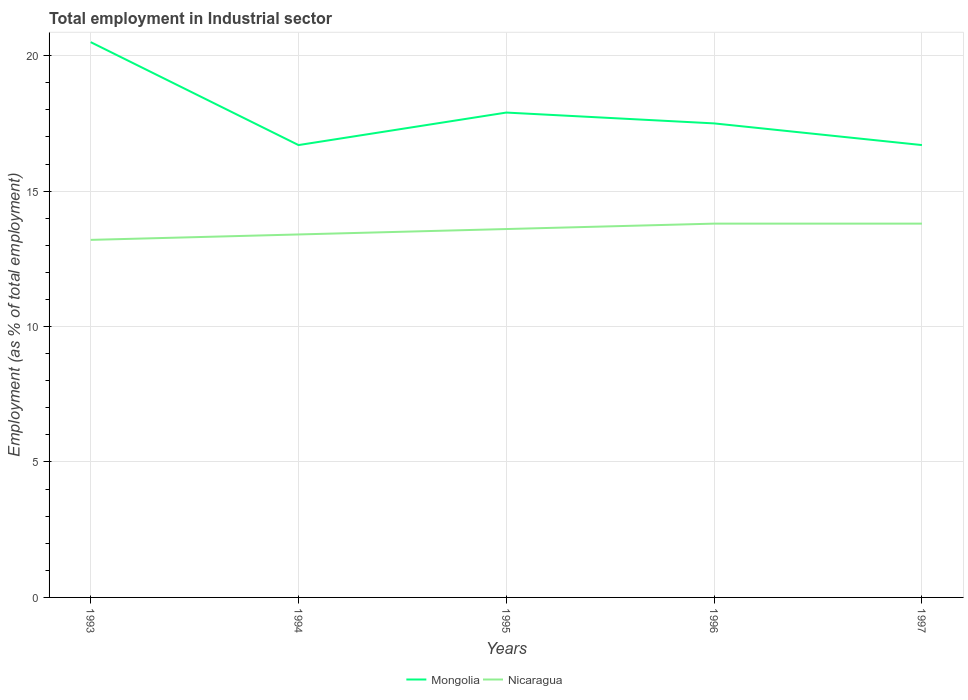How many different coloured lines are there?
Keep it short and to the point. 2. Does the line corresponding to Nicaragua intersect with the line corresponding to Mongolia?
Give a very brief answer. No. Is the number of lines equal to the number of legend labels?
Your response must be concise. Yes. Across all years, what is the maximum employment in industrial sector in Nicaragua?
Offer a terse response. 13.2. What is the total employment in industrial sector in Nicaragua in the graph?
Provide a succinct answer. -0.2. What is the difference between the highest and the second highest employment in industrial sector in Mongolia?
Provide a succinct answer. 3.8. What is the difference between the highest and the lowest employment in industrial sector in Nicaragua?
Offer a very short reply. 3. Is the employment in industrial sector in Mongolia strictly greater than the employment in industrial sector in Nicaragua over the years?
Offer a terse response. No. How many years are there in the graph?
Offer a very short reply. 5. Are the values on the major ticks of Y-axis written in scientific E-notation?
Your response must be concise. No. Does the graph contain any zero values?
Ensure brevity in your answer.  No. How many legend labels are there?
Your response must be concise. 2. What is the title of the graph?
Make the answer very short. Total employment in Industrial sector. What is the label or title of the X-axis?
Make the answer very short. Years. What is the label or title of the Y-axis?
Your answer should be very brief. Employment (as % of total employment). What is the Employment (as % of total employment) of Nicaragua in 1993?
Give a very brief answer. 13.2. What is the Employment (as % of total employment) of Mongolia in 1994?
Keep it short and to the point. 16.7. What is the Employment (as % of total employment) of Nicaragua in 1994?
Ensure brevity in your answer.  13.4. What is the Employment (as % of total employment) in Mongolia in 1995?
Your answer should be compact. 17.9. What is the Employment (as % of total employment) in Nicaragua in 1995?
Provide a short and direct response. 13.6. What is the Employment (as % of total employment) of Mongolia in 1996?
Your answer should be very brief. 17.5. What is the Employment (as % of total employment) in Nicaragua in 1996?
Offer a very short reply. 13.8. What is the Employment (as % of total employment) in Mongolia in 1997?
Keep it short and to the point. 16.7. What is the Employment (as % of total employment) in Nicaragua in 1997?
Your answer should be compact. 13.8. Across all years, what is the maximum Employment (as % of total employment) of Mongolia?
Give a very brief answer. 20.5. Across all years, what is the maximum Employment (as % of total employment) in Nicaragua?
Provide a succinct answer. 13.8. Across all years, what is the minimum Employment (as % of total employment) of Mongolia?
Your answer should be compact. 16.7. Across all years, what is the minimum Employment (as % of total employment) in Nicaragua?
Give a very brief answer. 13.2. What is the total Employment (as % of total employment) of Mongolia in the graph?
Your response must be concise. 89.3. What is the total Employment (as % of total employment) in Nicaragua in the graph?
Provide a short and direct response. 67.8. What is the difference between the Employment (as % of total employment) in Mongolia in 1993 and that in 1994?
Offer a terse response. 3.8. What is the difference between the Employment (as % of total employment) of Nicaragua in 1993 and that in 1996?
Your answer should be compact. -0.6. What is the difference between the Employment (as % of total employment) of Mongolia in 1993 and that in 1997?
Keep it short and to the point. 3.8. What is the difference between the Employment (as % of total employment) in Mongolia in 1994 and that in 1995?
Offer a very short reply. -1.2. What is the difference between the Employment (as % of total employment) of Nicaragua in 1994 and that in 1995?
Ensure brevity in your answer.  -0.2. What is the difference between the Employment (as % of total employment) in Mongolia in 1994 and that in 1997?
Provide a succinct answer. 0. What is the difference between the Employment (as % of total employment) of Nicaragua in 1994 and that in 1997?
Keep it short and to the point. -0.4. What is the difference between the Employment (as % of total employment) in Mongolia in 1995 and that in 1996?
Your answer should be compact. 0.4. What is the difference between the Employment (as % of total employment) in Nicaragua in 1995 and that in 1996?
Your response must be concise. -0.2. What is the difference between the Employment (as % of total employment) in Mongolia in 1995 and that in 1997?
Offer a terse response. 1.2. What is the difference between the Employment (as % of total employment) in Mongolia in 1996 and that in 1997?
Make the answer very short. 0.8. What is the difference between the Employment (as % of total employment) of Mongolia in 1993 and the Employment (as % of total employment) of Nicaragua in 1996?
Make the answer very short. 6.7. What is the difference between the Employment (as % of total employment) of Mongolia in 1994 and the Employment (as % of total employment) of Nicaragua in 1995?
Offer a terse response. 3.1. What is the difference between the Employment (as % of total employment) in Mongolia in 1994 and the Employment (as % of total employment) in Nicaragua in 1996?
Provide a short and direct response. 2.9. What is the difference between the Employment (as % of total employment) of Mongolia in 1994 and the Employment (as % of total employment) of Nicaragua in 1997?
Offer a very short reply. 2.9. What is the difference between the Employment (as % of total employment) in Mongolia in 1995 and the Employment (as % of total employment) in Nicaragua in 1997?
Provide a succinct answer. 4.1. What is the difference between the Employment (as % of total employment) of Mongolia in 1996 and the Employment (as % of total employment) of Nicaragua in 1997?
Your answer should be compact. 3.7. What is the average Employment (as % of total employment) in Mongolia per year?
Provide a short and direct response. 17.86. What is the average Employment (as % of total employment) in Nicaragua per year?
Give a very brief answer. 13.56. In the year 1993, what is the difference between the Employment (as % of total employment) of Mongolia and Employment (as % of total employment) of Nicaragua?
Provide a succinct answer. 7.3. In the year 1995, what is the difference between the Employment (as % of total employment) of Mongolia and Employment (as % of total employment) of Nicaragua?
Your response must be concise. 4.3. In the year 1996, what is the difference between the Employment (as % of total employment) of Mongolia and Employment (as % of total employment) of Nicaragua?
Offer a terse response. 3.7. In the year 1997, what is the difference between the Employment (as % of total employment) in Mongolia and Employment (as % of total employment) in Nicaragua?
Give a very brief answer. 2.9. What is the ratio of the Employment (as % of total employment) of Mongolia in 1993 to that in 1994?
Give a very brief answer. 1.23. What is the ratio of the Employment (as % of total employment) in Nicaragua in 1993 to that in 1994?
Your answer should be very brief. 0.99. What is the ratio of the Employment (as % of total employment) of Mongolia in 1993 to that in 1995?
Give a very brief answer. 1.15. What is the ratio of the Employment (as % of total employment) of Nicaragua in 1993 to that in 1995?
Your answer should be very brief. 0.97. What is the ratio of the Employment (as % of total employment) of Mongolia in 1993 to that in 1996?
Offer a very short reply. 1.17. What is the ratio of the Employment (as % of total employment) of Nicaragua in 1993 to that in 1996?
Provide a succinct answer. 0.96. What is the ratio of the Employment (as % of total employment) in Mongolia in 1993 to that in 1997?
Offer a terse response. 1.23. What is the ratio of the Employment (as % of total employment) of Nicaragua in 1993 to that in 1997?
Offer a very short reply. 0.96. What is the ratio of the Employment (as % of total employment) of Mongolia in 1994 to that in 1995?
Your answer should be very brief. 0.93. What is the ratio of the Employment (as % of total employment) of Nicaragua in 1994 to that in 1995?
Your response must be concise. 0.99. What is the ratio of the Employment (as % of total employment) of Mongolia in 1994 to that in 1996?
Your answer should be compact. 0.95. What is the ratio of the Employment (as % of total employment) in Mongolia in 1994 to that in 1997?
Provide a succinct answer. 1. What is the ratio of the Employment (as % of total employment) in Mongolia in 1995 to that in 1996?
Offer a very short reply. 1.02. What is the ratio of the Employment (as % of total employment) in Nicaragua in 1995 to that in 1996?
Make the answer very short. 0.99. What is the ratio of the Employment (as % of total employment) in Mongolia in 1995 to that in 1997?
Your answer should be very brief. 1.07. What is the ratio of the Employment (as % of total employment) of Nicaragua in 1995 to that in 1997?
Ensure brevity in your answer.  0.99. What is the ratio of the Employment (as % of total employment) in Mongolia in 1996 to that in 1997?
Provide a short and direct response. 1.05. What is the ratio of the Employment (as % of total employment) in Nicaragua in 1996 to that in 1997?
Ensure brevity in your answer.  1. What is the difference between the highest and the second highest Employment (as % of total employment) of Mongolia?
Ensure brevity in your answer.  2.6. What is the difference between the highest and the second highest Employment (as % of total employment) of Nicaragua?
Provide a succinct answer. 0. What is the difference between the highest and the lowest Employment (as % of total employment) of Mongolia?
Offer a very short reply. 3.8. What is the difference between the highest and the lowest Employment (as % of total employment) in Nicaragua?
Your answer should be compact. 0.6. 